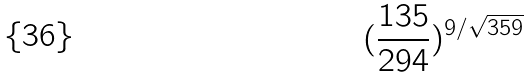<formula> <loc_0><loc_0><loc_500><loc_500>( \frac { 1 3 5 } { 2 9 4 } ) ^ { 9 / \sqrt { 3 5 9 } }</formula> 